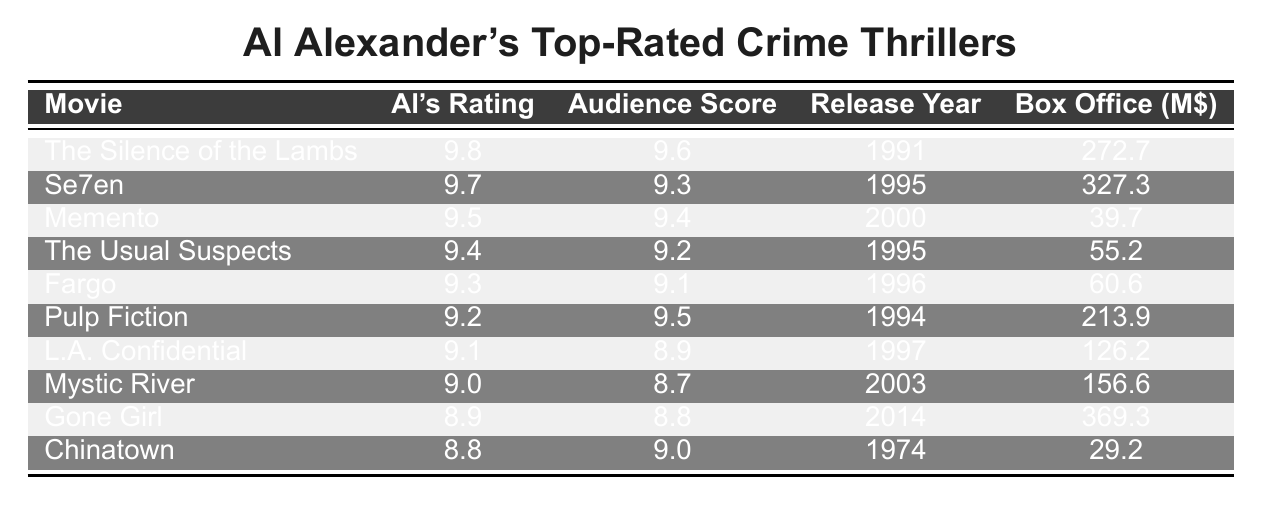What is the highest rating given by Al Alexander? The table lists Al Alexander's ratings, and the highest value is 9.8 for "The Silence of the Lambs."
Answer: 9.8 Which movie received the lowest audience score? By inspecting the audience scores in the table, the lowest score is 8.7 for "Mystic River."
Answer: 8.7 What is the average audience score for the movies listed? To calculate the average audience score, add all scores (9.6 + 9.3 + 9.4 + 9.2 + 9.1 + 9.5 + 8.9 + 8.7 + 8.8 + 9.0 =  91.5) and divide by the number of movies (10). The average is 91.5 / 10 = 9.15.
Answer: 9.15 Which movie released in 1995 has the highest rating from Al Alexander? The table shows two movies from 1995: "Se7en" (9.7) and "The Usual Suspects" (9.4). "Se7en" has the higher rating of 9.7.
Answer: Se7en What is the difference between Al Alexander's rating for "Pulp Fiction" and its audience score? The rating for "Pulp Fiction" is 9.2 and the audience score is 9.5. The difference is 9.5 - 9.2 = 0.3.
Answer: 0.3 Which movie has the highest box office gross, and what is that amount? By checking the "Box Office (M$)" column, "Gone Girl" has the highest gross of 369.3 million dollars.
Answer: 369.3 million Does any movie have an audience score higher than its Al Alexander rating? By examining the table, "Pulp Fiction" has an audience score of 9.5, which is higher than Al's rating of 9.2, making this statement true.
Answer: Yes Which movie has the lowest Al Alexander rating, and what is that rating? The lowest rating by Al Alexander is listed as 8.8 for "Chinatown."
Answer: 8.8 How many movies released after the year 2000 are rated 9 or higher by Al Alexander? The table lists three movies released after 2000: "Gone Girl" (8.9), and "Mystic River" (9.0). Only "Mystic River" has a rating of 9 or higher. So, there is one movie.
Answer: 1 What is the aggregate box office earnings for movies rated 9.5 and above by Al Alexander? Only the movies rated 9.5 and above are "The Silence of the Lambs" (272.7), "Se7en" (327.3), and "Memento" (39.7). Their total box office is 272.7 + 327.3 + 39.7 = 639.7 million.
Answer: 639.7 million 